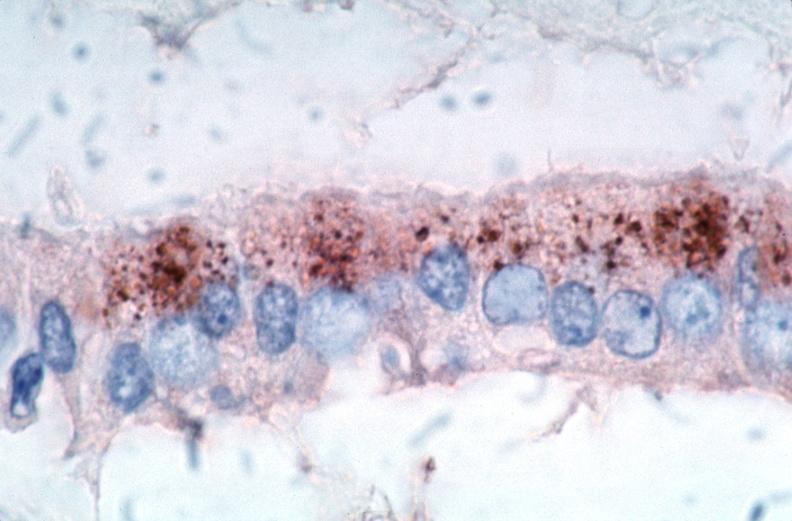what spotted fever , immunoperoxidase staining vessels for rickettsia rickettsii?
Answer the question using a single word or phrase. Vasculitis rocky mountain 